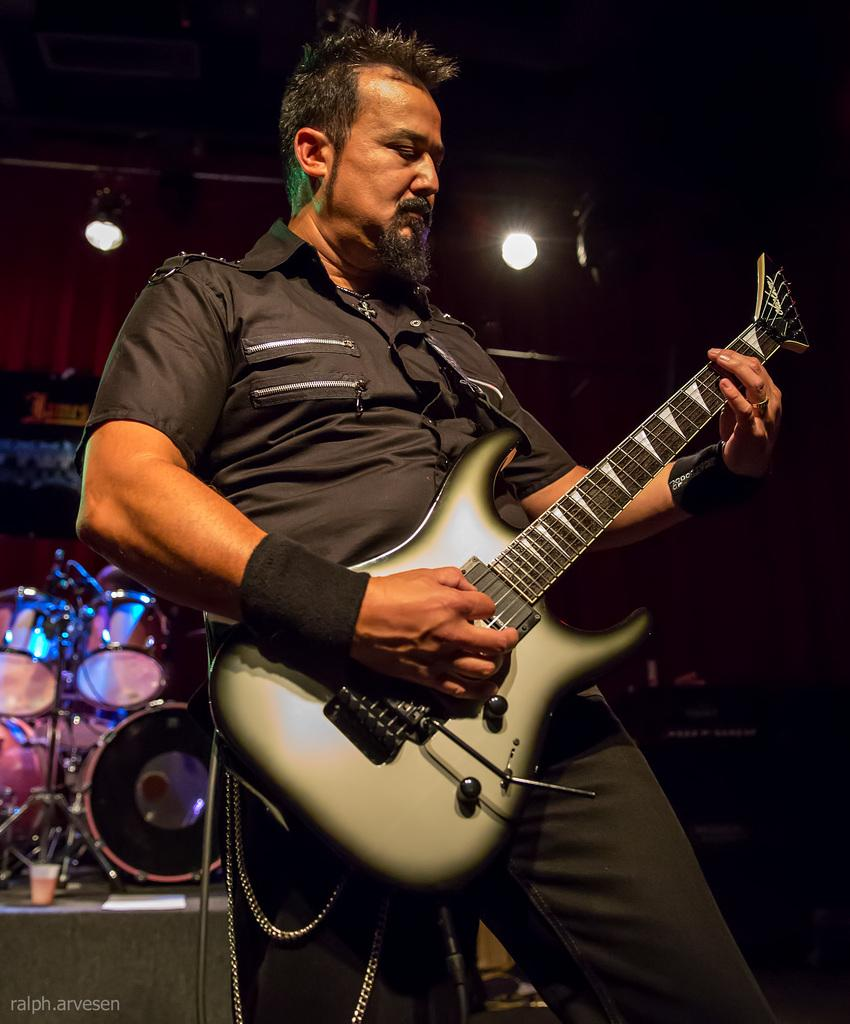What is the man in the image doing? The man is playing a guitar in the image. What musical instrument is also visible in the image? There is a drum kit in the image. How many cows are visible in the image? There are no cows present in the image; it features a man playing a guitar and a drum kit. 